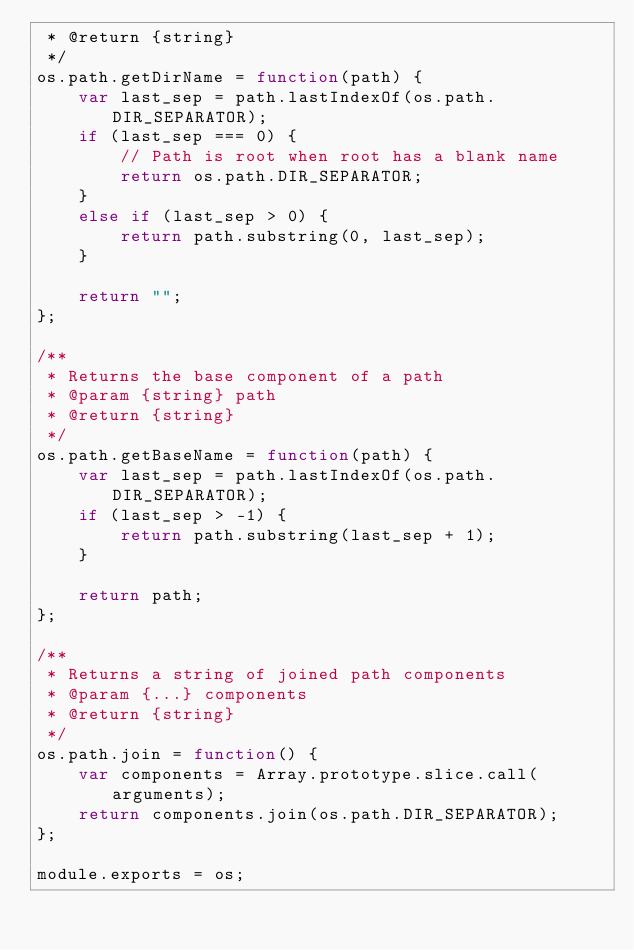<code> <loc_0><loc_0><loc_500><loc_500><_JavaScript_> * @return {string}
 */
os.path.getDirName = function(path) {
    var last_sep = path.lastIndexOf(os.path.DIR_SEPARATOR);
    if (last_sep === 0) {
        // Path is root when root has a blank name
        return os.path.DIR_SEPARATOR;
    }
    else if (last_sep > 0) {
        return path.substring(0, last_sep);
    }

    return "";
};

/**
 * Returns the base component of a path
 * @param {string} path
 * @return {string}
 */
os.path.getBaseName = function(path) {
    var last_sep = path.lastIndexOf(os.path.DIR_SEPARATOR);
    if (last_sep > -1) {
        return path.substring(last_sep + 1);
    }

    return path;
};

/**
 * Returns a string of joined path components
 * @param {...} components
 * @return {string}
 */
os.path.join = function() {
    var components = Array.prototype.slice.call(arguments);
    return components.join(os.path.DIR_SEPARATOR);
};

module.exports = os;
</code> 